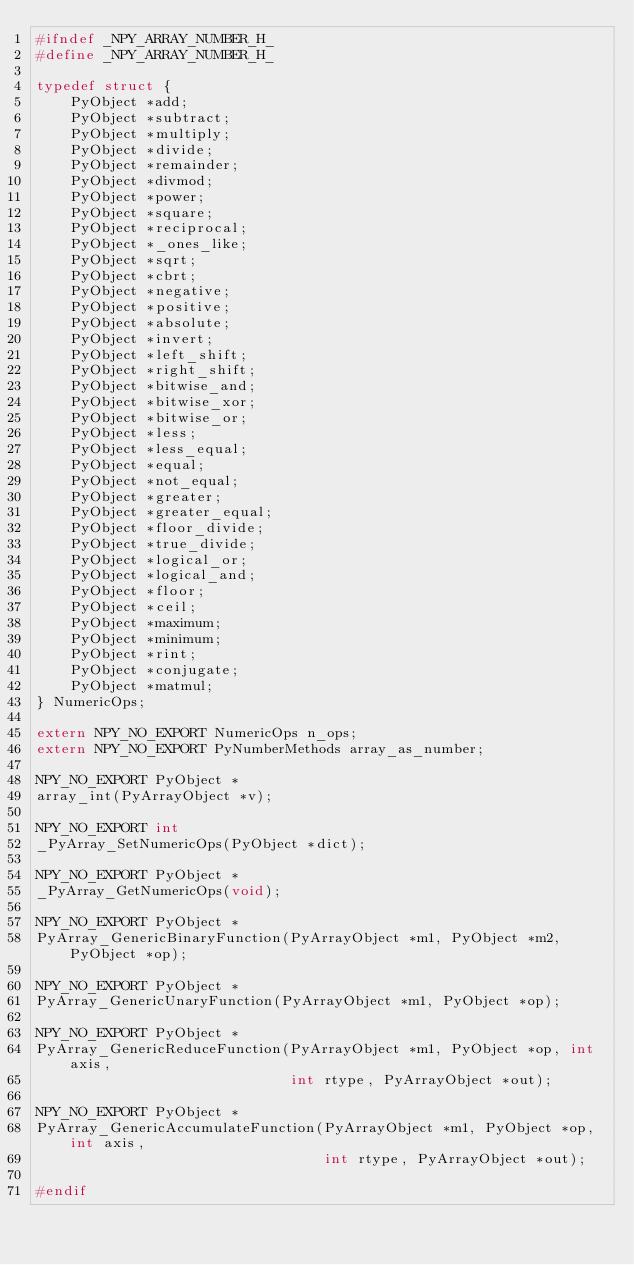Convert code to text. <code><loc_0><loc_0><loc_500><loc_500><_C_>#ifndef _NPY_ARRAY_NUMBER_H_
#define _NPY_ARRAY_NUMBER_H_

typedef struct {
    PyObject *add;
    PyObject *subtract;
    PyObject *multiply;
    PyObject *divide;
    PyObject *remainder;
    PyObject *divmod;
    PyObject *power;
    PyObject *square;
    PyObject *reciprocal;
    PyObject *_ones_like;
    PyObject *sqrt;
    PyObject *cbrt;
    PyObject *negative;
    PyObject *positive;
    PyObject *absolute;
    PyObject *invert;
    PyObject *left_shift;
    PyObject *right_shift;
    PyObject *bitwise_and;
    PyObject *bitwise_xor;
    PyObject *bitwise_or;
    PyObject *less;
    PyObject *less_equal;
    PyObject *equal;
    PyObject *not_equal;
    PyObject *greater;
    PyObject *greater_equal;
    PyObject *floor_divide;
    PyObject *true_divide;
    PyObject *logical_or;
    PyObject *logical_and;
    PyObject *floor;
    PyObject *ceil;
    PyObject *maximum;
    PyObject *minimum;
    PyObject *rint;
    PyObject *conjugate;
    PyObject *matmul;
} NumericOps;

extern NPY_NO_EXPORT NumericOps n_ops;
extern NPY_NO_EXPORT PyNumberMethods array_as_number;

NPY_NO_EXPORT PyObject *
array_int(PyArrayObject *v);

NPY_NO_EXPORT int
_PyArray_SetNumericOps(PyObject *dict);

NPY_NO_EXPORT PyObject *
_PyArray_GetNumericOps(void);

NPY_NO_EXPORT PyObject *
PyArray_GenericBinaryFunction(PyArrayObject *m1, PyObject *m2, PyObject *op);

NPY_NO_EXPORT PyObject *
PyArray_GenericUnaryFunction(PyArrayObject *m1, PyObject *op);

NPY_NO_EXPORT PyObject *
PyArray_GenericReduceFunction(PyArrayObject *m1, PyObject *op, int axis,
                              int rtype, PyArrayObject *out);

NPY_NO_EXPORT PyObject *
PyArray_GenericAccumulateFunction(PyArrayObject *m1, PyObject *op, int axis,
                                  int rtype, PyArrayObject *out);

#endif
</code> 